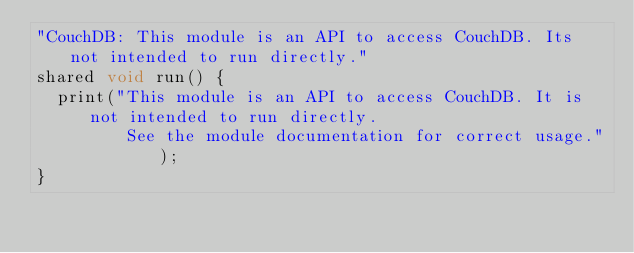Convert code to text. <code><loc_0><loc_0><loc_500><loc_500><_Ceylon_>"CouchDB: This module is an API to access CouchDB. Its not intended to run directly."
shared void run() {
	print("This module is an API to access CouchDB. It is not intended to run directly. 
	       See the module documentation for correct usage.");
}</code> 